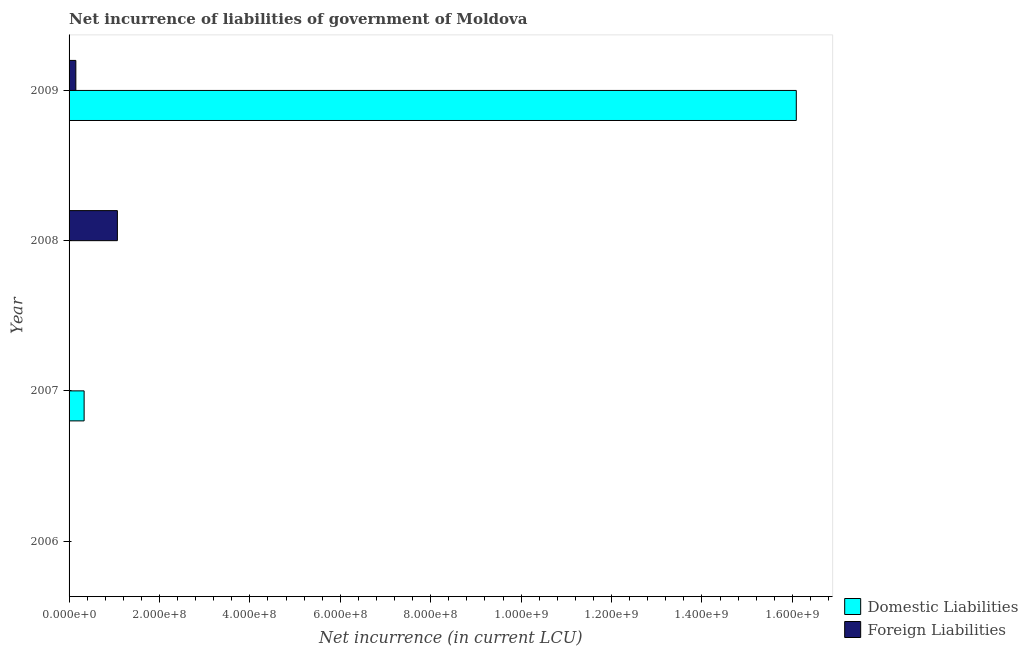Are the number of bars per tick equal to the number of legend labels?
Your answer should be very brief. No. Are the number of bars on each tick of the Y-axis equal?
Offer a very short reply. No. How many bars are there on the 2nd tick from the bottom?
Provide a short and direct response. 1. In how many cases, is the number of bars for a given year not equal to the number of legend labels?
Ensure brevity in your answer.  3. What is the net incurrence of foreign liabilities in 2006?
Your answer should be very brief. 0. Across all years, what is the maximum net incurrence of foreign liabilities?
Offer a very short reply. 1.07e+08. In which year was the net incurrence of foreign liabilities maximum?
Ensure brevity in your answer.  2008. What is the total net incurrence of domestic liabilities in the graph?
Make the answer very short. 1.64e+09. What is the difference between the net incurrence of foreign liabilities in 2008 and that in 2009?
Your answer should be very brief. 9.19e+07. What is the difference between the net incurrence of foreign liabilities in 2009 and the net incurrence of domestic liabilities in 2008?
Your answer should be compact. 1.50e+07. What is the average net incurrence of foreign liabilities per year?
Your answer should be very brief. 3.05e+07. In the year 2009, what is the difference between the net incurrence of foreign liabilities and net incurrence of domestic liabilities?
Provide a short and direct response. -1.59e+09. In how many years, is the net incurrence of foreign liabilities greater than 80000000 LCU?
Your response must be concise. 1. What is the ratio of the net incurrence of foreign liabilities in 2008 to that in 2009?
Make the answer very short. 7.13. What is the difference between the highest and the lowest net incurrence of domestic liabilities?
Provide a succinct answer. 1.61e+09. In how many years, is the net incurrence of domestic liabilities greater than the average net incurrence of domestic liabilities taken over all years?
Your answer should be very brief. 1. Is the sum of the net incurrence of foreign liabilities in 2008 and 2009 greater than the maximum net incurrence of domestic liabilities across all years?
Your answer should be very brief. No. How many bars are there?
Offer a very short reply. 4. What is the difference between two consecutive major ticks on the X-axis?
Make the answer very short. 2.00e+08. Does the graph contain any zero values?
Keep it short and to the point. Yes. How are the legend labels stacked?
Give a very brief answer. Vertical. What is the title of the graph?
Make the answer very short. Net incurrence of liabilities of government of Moldova. What is the label or title of the X-axis?
Ensure brevity in your answer.  Net incurrence (in current LCU). What is the Net incurrence (in current LCU) of Domestic Liabilities in 2007?
Provide a short and direct response. 3.33e+07. What is the Net incurrence (in current LCU) of Foreign Liabilities in 2007?
Ensure brevity in your answer.  0. What is the Net incurrence (in current LCU) in Domestic Liabilities in 2008?
Keep it short and to the point. 0. What is the Net incurrence (in current LCU) of Foreign Liabilities in 2008?
Give a very brief answer. 1.07e+08. What is the Net incurrence (in current LCU) of Domestic Liabilities in 2009?
Your answer should be compact. 1.61e+09. What is the Net incurrence (in current LCU) in Foreign Liabilities in 2009?
Your answer should be very brief. 1.50e+07. Across all years, what is the maximum Net incurrence (in current LCU) of Domestic Liabilities?
Offer a very short reply. 1.61e+09. Across all years, what is the maximum Net incurrence (in current LCU) of Foreign Liabilities?
Keep it short and to the point. 1.07e+08. Across all years, what is the minimum Net incurrence (in current LCU) of Domestic Liabilities?
Your response must be concise. 0. Across all years, what is the minimum Net incurrence (in current LCU) in Foreign Liabilities?
Ensure brevity in your answer.  0. What is the total Net incurrence (in current LCU) of Domestic Liabilities in the graph?
Offer a terse response. 1.64e+09. What is the total Net incurrence (in current LCU) of Foreign Liabilities in the graph?
Your answer should be compact. 1.22e+08. What is the difference between the Net incurrence (in current LCU) of Domestic Liabilities in 2007 and that in 2009?
Keep it short and to the point. -1.58e+09. What is the difference between the Net incurrence (in current LCU) of Foreign Liabilities in 2008 and that in 2009?
Offer a very short reply. 9.19e+07. What is the difference between the Net incurrence (in current LCU) in Domestic Liabilities in 2007 and the Net incurrence (in current LCU) in Foreign Liabilities in 2008?
Give a very brief answer. -7.36e+07. What is the difference between the Net incurrence (in current LCU) in Domestic Liabilities in 2007 and the Net incurrence (in current LCU) in Foreign Liabilities in 2009?
Make the answer very short. 1.83e+07. What is the average Net incurrence (in current LCU) in Domestic Liabilities per year?
Provide a succinct answer. 4.11e+08. What is the average Net incurrence (in current LCU) of Foreign Liabilities per year?
Provide a short and direct response. 3.05e+07. In the year 2009, what is the difference between the Net incurrence (in current LCU) in Domestic Liabilities and Net incurrence (in current LCU) in Foreign Liabilities?
Your answer should be compact. 1.59e+09. What is the ratio of the Net incurrence (in current LCU) in Domestic Liabilities in 2007 to that in 2009?
Ensure brevity in your answer.  0.02. What is the ratio of the Net incurrence (in current LCU) in Foreign Liabilities in 2008 to that in 2009?
Offer a very short reply. 7.13. What is the difference between the highest and the lowest Net incurrence (in current LCU) of Domestic Liabilities?
Make the answer very short. 1.61e+09. What is the difference between the highest and the lowest Net incurrence (in current LCU) of Foreign Liabilities?
Provide a succinct answer. 1.07e+08. 